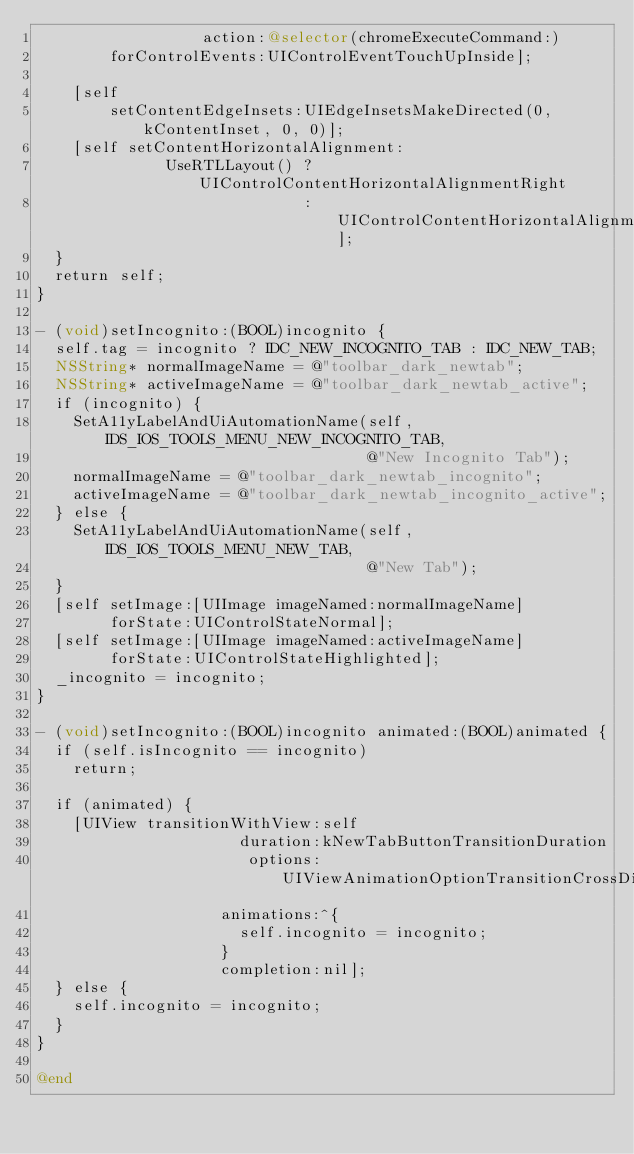Convert code to text. <code><loc_0><loc_0><loc_500><loc_500><_ObjectiveC_>                  action:@selector(chromeExecuteCommand:)
        forControlEvents:UIControlEventTouchUpInside];

    [self
        setContentEdgeInsets:UIEdgeInsetsMakeDirected(0, kContentInset, 0, 0)];
    [self setContentHorizontalAlignment:
              UseRTLLayout() ? UIControlContentHorizontalAlignmentRight
                             : UIControlContentHorizontalAlignmentLeft];
  }
  return self;
}

- (void)setIncognito:(BOOL)incognito {
  self.tag = incognito ? IDC_NEW_INCOGNITO_TAB : IDC_NEW_TAB;
  NSString* normalImageName = @"toolbar_dark_newtab";
  NSString* activeImageName = @"toolbar_dark_newtab_active";
  if (incognito) {
    SetA11yLabelAndUiAutomationName(self, IDS_IOS_TOOLS_MENU_NEW_INCOGNITO_TAB,
                                    @"New Incognito Tab");
    normalImageName = @"toolbar_dark_newtab_incognito";
    activeImageName = @"toolbar_dark_newtab_incognito_active";
  } else {
    SetA11yLabelAndUiAutomationName(self, IDS_IOS_TOOLS_MENU_NEW_TAB,
                                    @"New Tab");
  }
  [self setImage:[UIImage imageNamed:normalImageName]
        forState:UIControlStateNormal];
  [self setImage:[UIImage imageNamed:activeImageName]
        forState:UIControlStateHighlighted];
  _incognito = incognito;
}

- (void)setIncognito:(BOOL)incognito animated:(BOOL)animated {
  if (self.isIncognito == incognito)
    return;

  if (animated) {
    [UIView transitionWithView:self
                      duration:kNewTabButtonTransitionDuration
                       options:UIViewAnimationOptionTransitionCrossDissolve
                    animations:^{
                      self.incognito = incognito;
                    }
                    completion:nil];
  } else {
    self.incognito = incognito;
  }
}

@end
</code> 